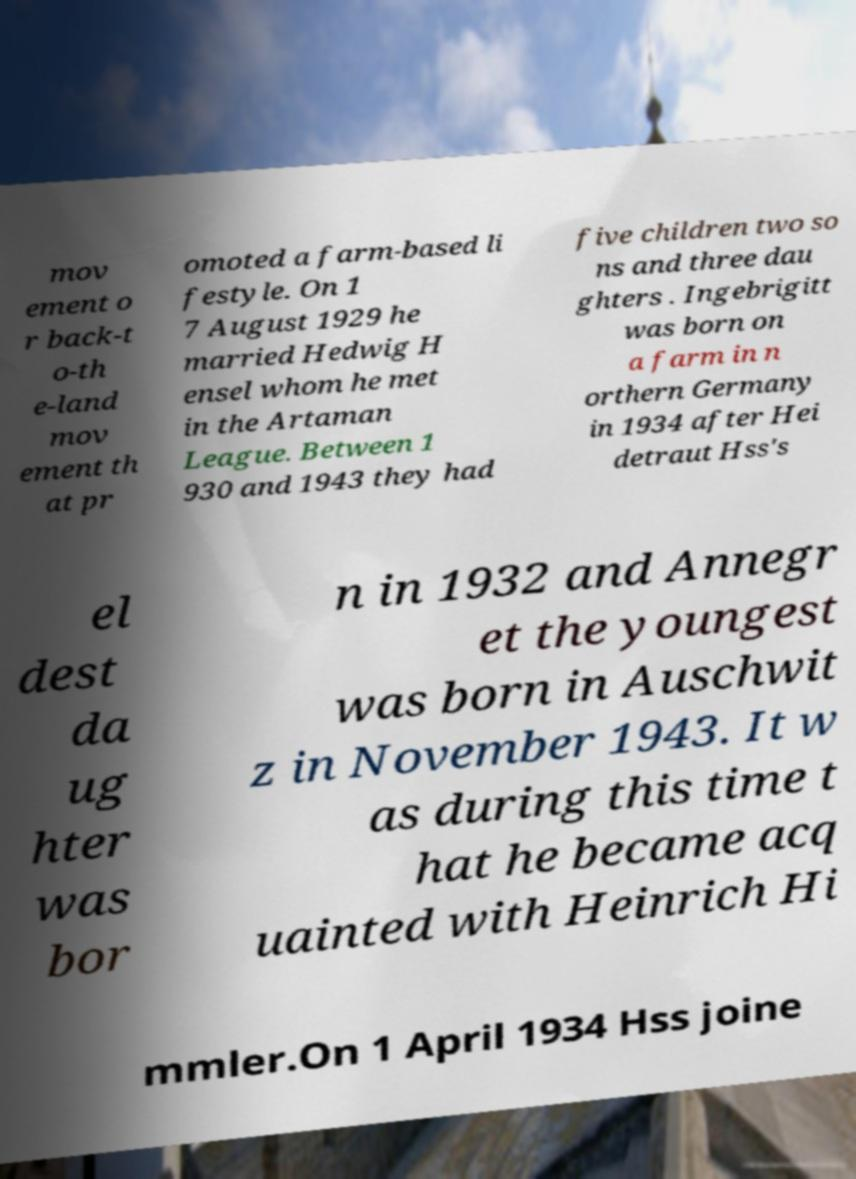Can you accurately transcribe the text from the provided image for me? mov ement o r back-t o-th e-land mov ement th at pr omoted a farm-based li festyle. On 1 7 August 1929 he married Hedwig H ensel whom he met in the Artaman League. Between 1 930 and 1943 they had five children two so ns and three dau ghters . Ingebrigitt was born on a farm in n orthern Germany in 1934 after Hei detraut Hss's el dest da ug hter was bor n in 1932 and Annegr et the youngest was born in Auschwit z in November 1943. It w as during this time t hat he became acq uainted with Heinrich Hi mmler.On 1 April 1934 Hss joine 